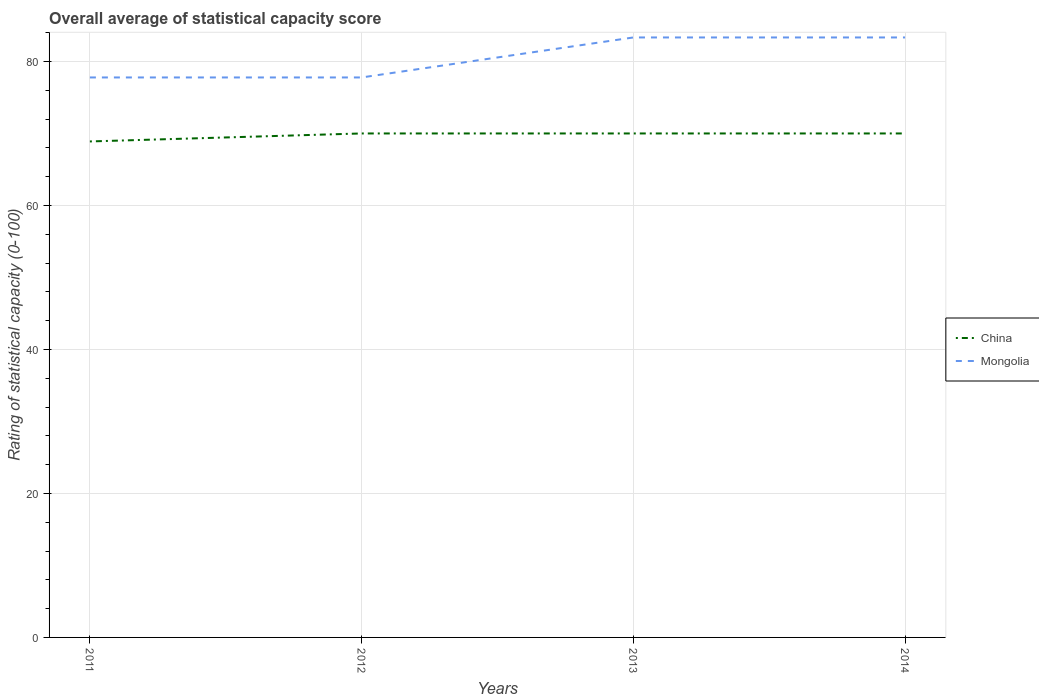Does the line corresponding to China intersect with the line corresponding to Mongolia?
Offer a very short reply. No. Across all years, what is the maximum rating of statistical capacity in China?
Offer a very short reply. 68.89. In which year was the rating of statistical capacity in China maximum?
Offer a very short reply. 2011. What is the total rating of statistical capacity in Mongolia in the graph?
Your answer should be compact. -5.56. What is the difference between the highest and the second highest rating of statistical capacity in China?
Make the answer very short. 1.11. How many years are there in the graph?
Make the answer very short. 4. How many legend labels are there?
Offer a very short reply. 2. What is the title of the graph?
Provide a succinct answer. Overall average of statistical capacity score. Does "St. Lucia" appear as one of the legend labels in the graph?
Provide a short and direct response. No. What is the label or title of the Y-axis?
Keep it short and to the point. Rating of statistical capacity (0-100). What is the Rating of statistical capacity (0-100) of China in 2011?
Provide a succinct answer. 68.89. What is the Rating of statistical capacity (0-100) of Mongolia in 2011?
Give a very brief answer. 77.78. What is the Rating of statistical capacity (0-100) in China in 2012?
Offer a terse response. 70. What is the Rating of statistical capacity (0-100) in Mongolia in 2012?
Give a very brief answer. 77.78. What is the Rating of statistical capacity (0-100) of China in 2013?
Make the answer very short. 70. What is the Rating of statistical capacity (0-100) in Mongolia in 2013?
Give a very brief answer. 83.33. What is the Rating of statistical capacity (0-100) in Mongolia in 2014?
Ensure brevity in your answer.  83.33. Across all years, what is the maximum Rating of statistical capacity (0-100) in Mongolia?
Your answer should be very brief. 83.33. Across all years, what is the minimum Rating of statistical capacity (0-100) of China?
Ensure brevity in your answer.  68.89. Across all years, what is the minimum Rating of statistical capacity (0-100) of Mongolia?
Keep it short and to the point. 77.78. What is the total Rating of statistical capacity (0-100) in China in the graph?
Your response must be concise. 278.89. What is the total Rating of statistical capacity (0-100) of Mongolia in the graph?
Your response must be concise. 322.22. What is the difference between the Rating of statistical capacity (0-100) in China in 2011 and that in 2012?
Give a very brief answer. -1.11. What is the difference between the Rating of statistical capacity (0-100) in Mongolia in 2011 and that in 2012?
Provide a short and direct response. 0. What is the difference between the Rating of statistical capacity (0-100) of China in 2011 and that in 2013?
Provide a short and direct response. -1.11. What is the difference between the Rating of statistical capacity (0-100) of Mongolia in 2011 and that in 2013?
Offer a terse response. -5.56. What is the difference between the Rating of statistical capacity (0-100) of China in 2011 and that in 2014?
Your response must be concise. -1.11. What is the difference between the Rating of statistical capacity (0-100) in Mongolia in 2011 and that in 2014?
Offer a terse response. -5.56. What is the difference between the Rating of statistical capacity (0-100) of China in 2012 and that in 2013?
Provide a succinct answer. 0. What is the difference between the Rating of statistical capacity (0-100) of Mongolia in 2012 and that in 2013?
Your answer should be compact. -5.56. What is the difference between the Rating of statistical capacity (0-100) in China in 2012 and that in 2014?
Provide a short and direct response. 0. What is the difference between the Rating of statistical capacity (0-100) of Mongolia in 2012 and that in 2014?
Make the answer very short. -5.56. What is the difference between the Rating of statistical capacity (0-100) in China in 2013 and that in 2014?
Keep it short and to the point. 0. What is the difference between the Rating of statistical capacity (0-100) in Mongolia in 2013 and that in 2014?
Provide a short and direct response. 0. What is the difference between the Rating of statistical capacity (0-100) in China in 2011 and the Rating of statistical capacity (0-100) in Mongolia in 2012?
Give a very brief answer. -8.89. What is the difference between the Rating of statistical capacity (0-100) in China in 2011 and the Rating of statistical capacity (0-100) in Mongolia in 2013?
Offer a terse response. -14.44. What is the difference between the Rating of statistical capacity (0-100) in China in 2011 and the Rating of statistical capacity (0-100) in Mongolia in 2014?
Offer a very short reply. -14.44. What is the difference between the Rating of statistical capacity (0-100) in China in 2012 and the Rating of statistical capacity (0-100) in Mongolia in 2013?
Ensure brevity in your answer.  -13.33. What is the difference between the Rating of statistical capacity (0-100) in China in 2012 and the Rating of statistical capacity (0-100) in Mongolia in 2014?
Provide a short and direct response. -13.33. What is the difference between the Rating of statistical capacity (0-100) in China in 2013 and the Rating of statistical capacity (0-100) in Mongolia in 2014?
Your answer should be very brief. -13.33. What is the average Rating of statistical capacity (0-100) in China per year?
Your answer should be compact. 69.72. What is the average Rating of statistical capacity (0-100) in Mongolia per year?
Make the answer very short. 80.56. In the year 2011, what is the difference between the Rating of statistical capacity (0-100) of China and Rating of statistical capacity (0-100) of Mongolia?
Your response must be concise. -8.89. In the year 2012, what is the difference between the Rating of statistical capacity (0-100) in China and Rating of statistical capacity (0-100) in Mongolia?
Your answer should be compact. -7.78. In the year 2013, what is the difference between the Rating of statistical capacity (0-100) in China and Rating of statistical capacity (0-100) in Mongolia?
Your answer should be compact. -13.33. In the year 2014, what is the difference between the Rating of statistical capacity (0-100) in China and Rating of statistical capacity (0-100) in Mongolia?
Ensure brevity in your answer.  -13.33. What is the ratio of the Rating of statistical capacity (0-100) of China in 2011 to that in 2012?
Offer a very short reply. 0.98. What is the ratio of the Rating of statistical capacity (0-100) in Mongolia in 2011 to that in 2012?
Keep it short and to the point. 1. What is the ratio of the Rating of statistical capacity (0-100) of China in 2011 to that in 2013?
Keep it short and to the point. 0.98. What is the ratio of the Rating of statistical capacity (0-100) in China in 2011 to that in 2014?
Make the answer very short. 0.98. What is the ratio of the Rating of statistical capacity (0-100) in Mongolia in 2012 to that in 2013?
Your response must be concise. 0.93. What is the ratio of the Rating of statistical capacity (0-100) of China in 2012 to that in 2014?
Your response must be concise. 1. What is the ratio of the Rating of statistical capacity (0-100) of China in 2013 to that in 2014?
Provide a short and direct response. 1. What is the ratio of the Rating of statistical capacity (0-100) of Mongolia in 2013 to that in 2014?
Make the answer very short. 1. What is the difference between the highest and the second highest Rating of statistical capacity (0-100) in Mongolia?
Ensure brevity in your answer.  0. What is the difference between the highest and the lowest Rating of statistical capacity (0-100) of China?
Give a very brief answer. 1.11. What is the difference between the highest and the lowest Rating of statistical capacity (0-100) of Mongolia?
Keep it short and to the point. 5.56. 